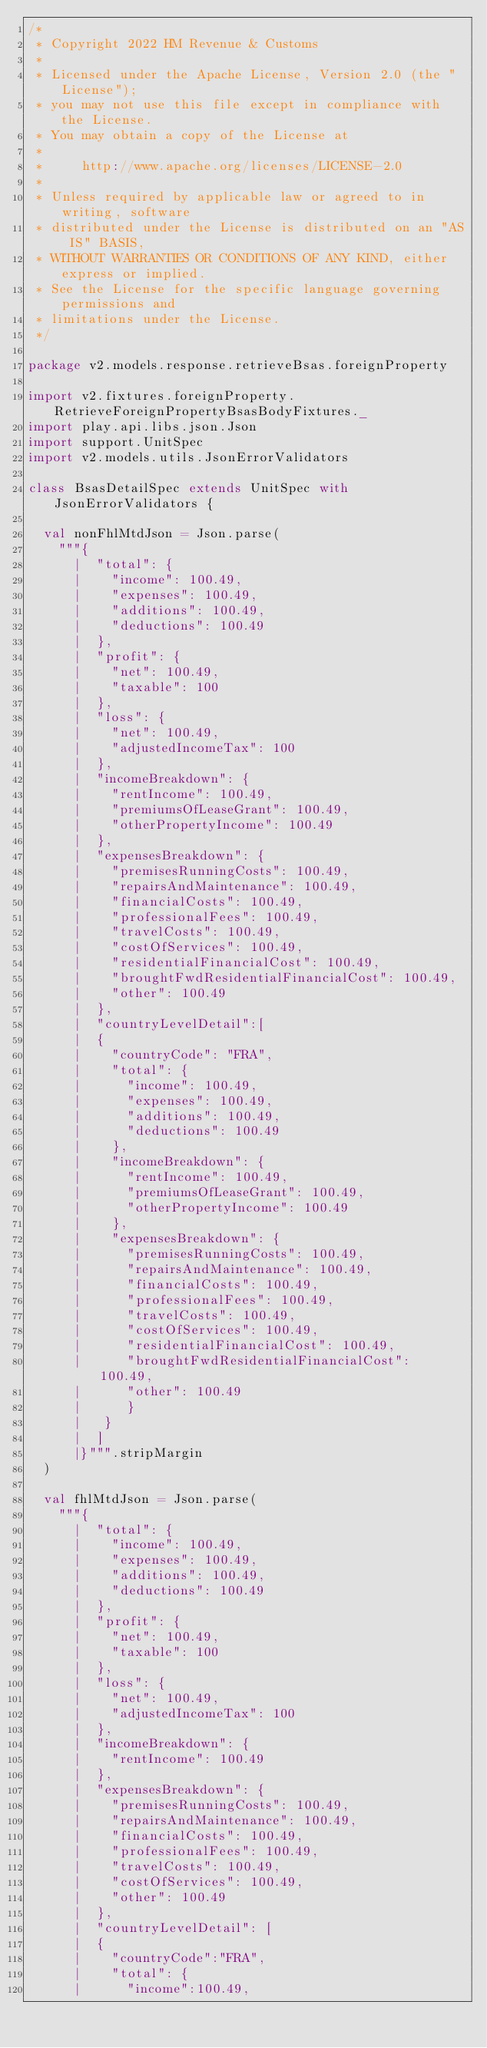<code> <loc_0><loc_0><loc_500><loc_500><_Scala_>/*
 * Copyright 2022 HM Revenue & Customs
 *
 * Licensed under the Apache License, Version 2.0 (the "License");
 * you may not use this file except in compliance with the License.
 * You may obtain a copy of the License at
 *
 *     http://www.apache.org/licenses/LICENSE-2.0
 *
 * Unless required by applicable law or agreed to in writing, software
 * distributed under the License is distributed on an "AS IS" BASIS,
 * WITHOUT WARRANTIES OR CONDITIONS OF ANY KIND, either express or implied.
 * See the License for the specific language governing permissions and
 * limitations under the License.
 */

package v2.models.response.retrieveBsas.foreignProperty

import v2.fixtures.foreignProperty.RetrieveForeignPropertyBsasBodyFixtures._
import play.api.libs.json.Json
import support.UnitSpec
import v2.models.utils.JsonErrorValidators

class BsasDetailSpec extends UnitSpec with JsonErrorValidators {

  val nonFhlMtdJson = Json.parse(
    """{
      |  "total": {
      |    "income": 100.49,
      |    "expenses": 100.49,
      |    "additions": 100.49,
      |    "deductions": 100.49
      |  },
      |  "profit": {
      |    "net": 100.49,
      |    "taxable": 100
      |  },
      |  "loss": {
      |    "net": 100.49,
      |    "adjustedIncomeTax": 100
      |  },
      |  "incomeBreakdown": {
      |    "rentIncome": 100.49,
      |    "premiumsOfLeaseGrant": 100.49,
      |    "otherPropertyIncome": 100.49
      |  },
      |  "expensesBreakdown": {
      |    "premisesRunningCosts": 100.49,
      |    "repairsAndMaintenance": 100.49,
      |    "financialCosts": 100.49,
      |    "professionalFees": 100.49,
      |    "travelCosts": 100.49,
      |    "costOfServices": 100.49,
      |    "residentialFinancialCost": 100.49,
      |    "broughtFwdResidentialFinancialCost": 100.49,
      |    "other": 100.49
      |  },
      |  "countryLevelDetail":[
      |  {
      |    "countryCode": "FRA",
      |    "total": {
      |      "income": 100.49,
      |      "expenses": 100.49,
      |      "additions": 100.49,
      |      "deductions": 100.49
      |    },
      |    "incomeBreakdown": {
      |      "rentIncome": 100.49,
      |      "premiumsOfLeaseGrant": 100.49,
      |      "otherPropertyIncome": 100.49
      |    },
      |    "expensesBreakdown": {
      |      "premisesRunningCosts": 100.49,
      |      "repairsAndMaintenance": 100.49,
      |      "financialCosts": 100.49,
      |      "professionalFees": 100.49,
      |      "travelCosts": 100.49,
      |      "costOfServices": 100.49,
      |      "residentialFinancialCost": 100.49,
      |      "broughtFwdResidentialFinancialCost": 100.49,
      |      "other": 100.49
      |      }
      |   }
      |  ]
      |}""".stripMargin
  )

  val fhlMtdJson = Json.parse(
    """{
      |  "total": {
      |    "income": 100.49,
      |    "expenses": 100.49,
      |    "additions": 100.49,
      |    "deductions": 100.49
      |  },
      |  "profit": {
      |    "net": 100.49,
      |    "taxable": 100
      |  },
      |  "loss": {
      |    "net": 100.49,
      |    "adjustedIncomeTax": 100
      |  },
      |  "incomeBreakdown": {
      |    "rentIncome": 100.49
      |  },
      |  "expensesBreakdown": {
      |    "premisesRunningCosts": 100.49,
      |    "repairsAndMaintenance": 100.49,
      |    "financialCosts": 100.49,
      |    "professionalFees": 100.49,
      |    "travelCosts": 100.49,
      |    "costOfServices": 100.49,
      |    "other": 100.49
      |  },
      |  "countryLevelDetail": [
      |  {
      |    "countryCode":"FRA",
      |    "total": {
      |      "income":100.49,</code> 